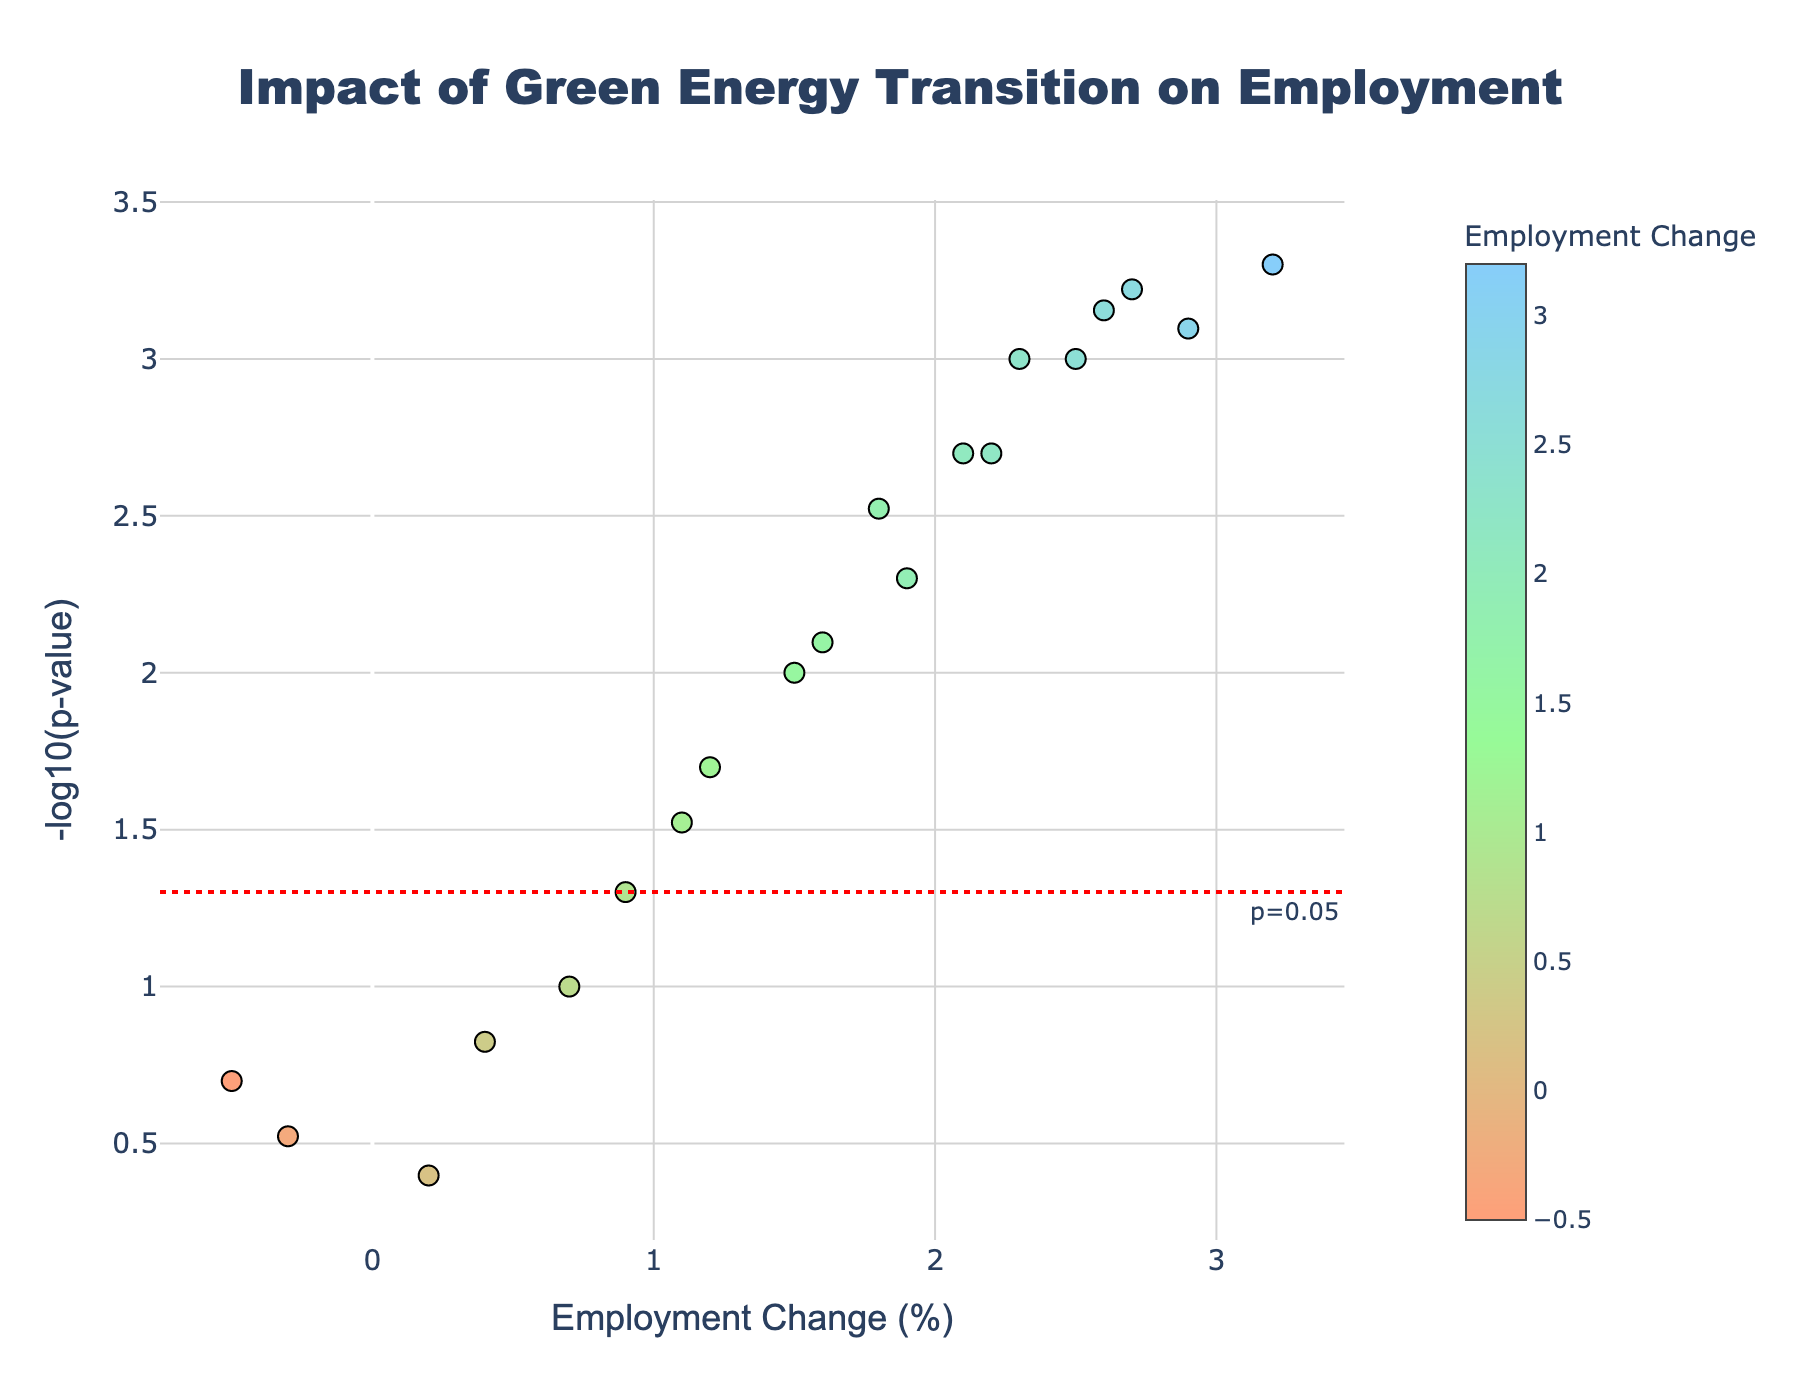What is the title of the plot? The title of the plot is always prominently displayed at the top. In this plot, it reads "Impact of Green Energy Transition on Employment".
Answer: Impact of Green Energy Transition on Employment Which country has the highest employment change? By looking at the x-axis, which represents Employment Change (%), the country with the highest positive value is clearly farthest to the right. Observing the plot, China has the highest employment change of 3.2%.
Answer: China How many countries have a p-value below 0.05? The y-axis represents the -log10(p-value). The red horizontal line indicates the p-value threshold of 0.05. Countries above this line have p-values below 0.05. By counting the points above this line, we see there are 13 countries.
Answer: 13 Which country has the least significant p-value? The significance of the p-value is indicated by its position on the y-axis. The further down, the higher the p-value. South Africa has the lowest position on the y-axis.
Answer: South Africa What is the employment change for Norway? Hovering over the data points will reveal country names and their respective values. For Norway, the data point is located at an employment change of 2.2%.
Answer: 2.2% How many countries show a negative employment change? Negative employment change points will be located to the left of the zero line on the x-axis. There are two countries with negative employment changes: Brazil and Poland.
Answer: 2 Which country has an employment change closest to 0? The employment change closest to 0 will be the point nearest to the y-axis. South Africa, with an employment change of 0.2, is the closest.
Answer: South Africa Of the countries with a p-value below 0.05, which has the lowest employment change? First, identify the data points above the red line (p-value threshold). Then, find the one with the smallest x-axis value (employment change). Spain, with an employment change of 1.2%, is the lowest among these.
Answer: Spain Which countries have an employment change greater than 2.5% but less than 3%? Look for data points between the 2.5% and 3% marks on the x-axis. The countries in this range are Sweden, Denmark, and Netherlands.
Answer: Sweden, Denmark, Netherlands 